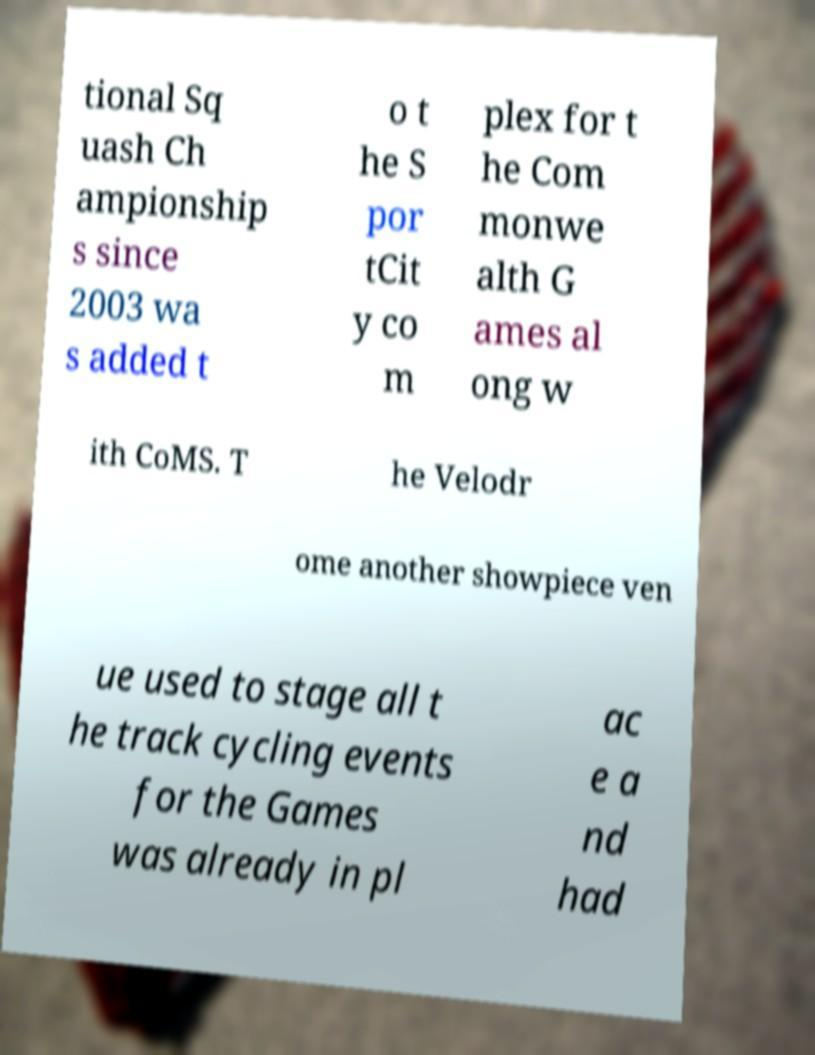For documentation purposes, I need the text within this image transcribed. Could you provide that? tional Sq uash Ch ampionship s since 2003 wa s added t o t he S por tCit y co m plex for t he Com monwe alth G ames al ong w ith CoMS. T he Velodr ome another showpiece ven ue used to stage all t he track cycling events for the Games was already in pl ac e a nd had 